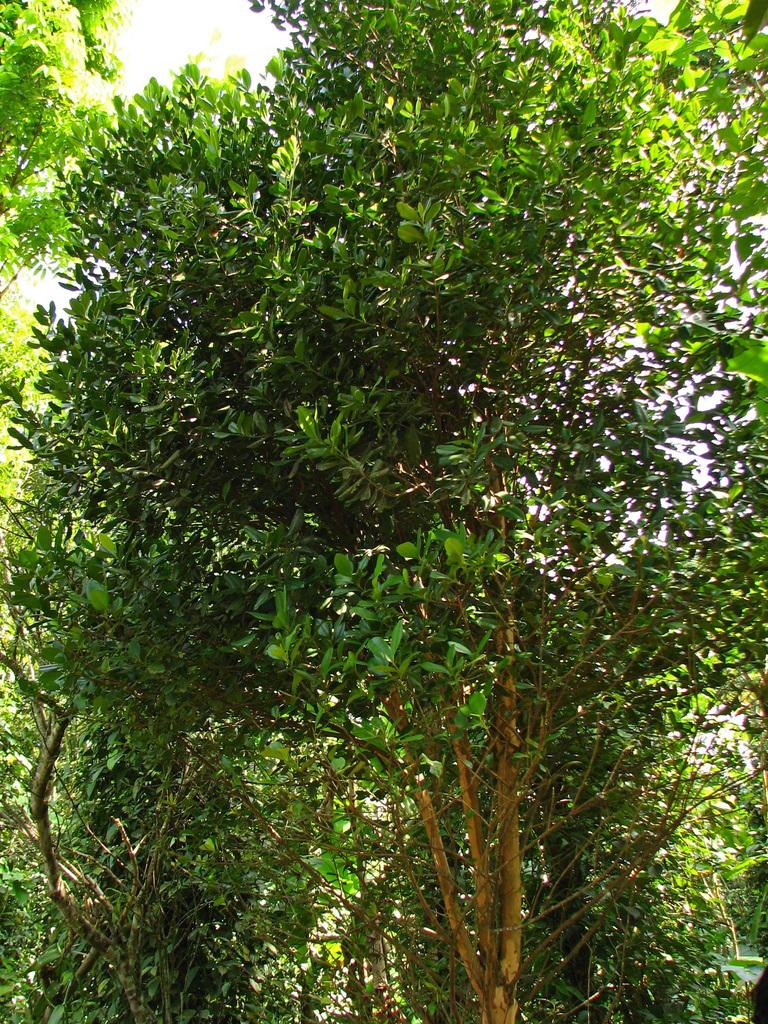What type of vegetation can be seen in the image? There are trees in the image. What is the color of the trees in the image? The trees are green in color. What else is visible in the image besides the trees? The sky is visible in the image. What is the color of the sky in the image? The sky is white in color. Can you see any dolls playing by the river in the image? There is no river or dolls present in the image. 